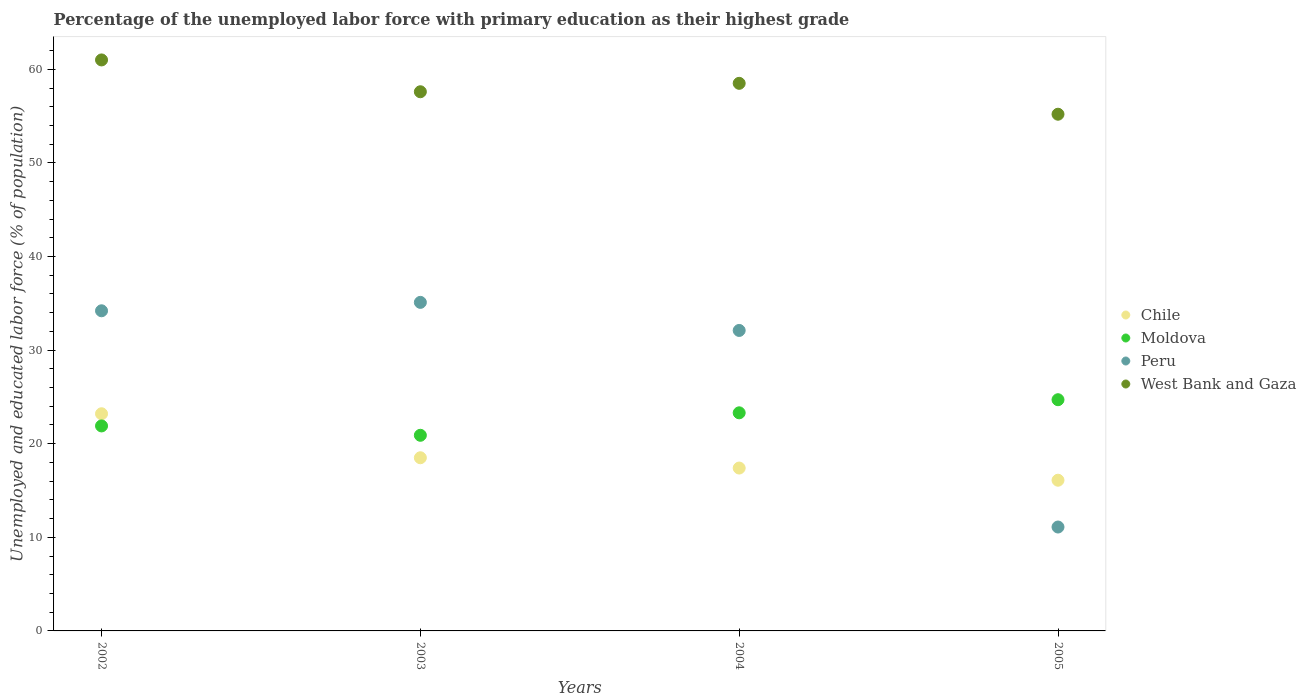How many different coloured dotlines are there?
Make the answer very short. 4. Is the number of dotlines equal to the number of legend labels?
Your response must be concise. Yes. What is the percentage of the unemployed labor force with primary education in Moldova in 2003?
Provide a succinct answer. 20.9. Across all years, what is the maximum percentage of the unemployed labor force with primary education in Chile?
Make the answer very short. 23.2. Across all years, what is the minimum percentage of the unemployed labor force with primary education in Peru?
Ensure brevity in your answer.  11.1. What is the total percentage of the unemployed labor force with primary education in Moldova in the graph?
Your answer should be very brief. 90.8. What is the difference between the percentage of the unemployed labor force with primary education in Peru in 2002 and that in 2004?
Offer a very short reply. 2.1. What is the difference between the percentage of the unemployed labor force with primary education in Chile in 2004 and the percentage of the unemployed labor force with primary education in West Bank and Gaza in 2005?
Offer a very short reply. -37.8. What is the average percentage of the unemployed labor force with primary education in Chile per year?
Offer a terse response. 18.8. In the year 2003, what is the difference between the percentage of the unemployed labor force with primary education in Peru and percentage of the unemployed labor force with primary education in West Bank and Gaza?
Offer a very short reply. -22.5. What is the ratio of the percentage of the unemployed labor force with primary education in Moldova in 2003 to that in 2005?
Your response must be concise. 0.85. What is the difference between the highest and the second highest percentage of the unemployed labor force with primary education in Peru?
Provide a succinct answer. 0.9. What is the difference between the highest and the lowest percentage of the unemployed labor force with primary education in Peru?
Provide a succinct answer. 24. In how many years, is the percentage of the unemployed labor force with primary education in Moldova greater than the average percentage of the unemployed labor force with primary education in Moldova taken over all years?
Your response must be concise. 2. Is it the case that in every year, the sum of the percentage of the unemployed labor force with primary education in Moldova and percentage of the unemployed labor force with primary education in West Bank and Gaza  is greater than the percentage of the unemployed labor force with primary education in Peru?
Offer a terse response. Yes. Does the percentage of the unemployed labor force with primary education in Peru monotonically increase over the years?
Your response must be concise. No. Is the percentage of the unemployed labor force with primary education in West Bank and Gaza strictly greater than the percentage of the unemployed labor force with primary education in Peru over the years?
Make the answer very short. Yes. Is the percentage of the unemployed labor force with primary education in Peru strictly less than the percentage of the unemployed labor force with primary education in Moldova over the years?
Your answer should be compact. No. How many dotlines are there?
Ensure brevity in your answer.  4. Are the values on the major ticks of Y-axis written in scientific E-notation?
Provide a succinct answer. No. Does the graph contain any zero values?
Offer a very short reply. No. Where does the legend appear in the graph?
Offer a very short reply. Center right. How many legend labels are there?
Offer a terse response. 4. What is the title of the graph?
Ensure brevity in your answer.  Percentage of the unemployed labor force with primary education as their highest grade. Does "Papua New Guinea" appear as one of the legend labels in the graph?
Your answer should be compact. No. What is the label or title of the Y-axis?
Your response must be concise. Unemployed and educated labor force (% of population). What is the Unemployed and educated labor force (% of population) in Chile in 2002?
Your answer should be compact. 23.2. What is the Unemployed and educated labor force (% of population) of Moldova in 2002?
Make the answer very short. 21.9. What is the Unemployed and educated labor force (% of population) in Peru in 2002?
Give a very brief answer. 34.2. What is the Unemployed and educated labor force (% of population) in Chile in 2003?
Keep it short and to the point. 18.5. What is the Unemployed and educated labor force (% of population) of Moldova in 2003?
Ensure brevity in your answer.  20.9. What is the Unemployed and educated labor force (% of population) of Peru in 2003?
Offer a terse response. 35.1. What is the Unemployed and educated labor force (% of population) in West Bank and Gaza in 2003?
Offer a terse response. 57.6. What is the Unemployed and educated labor force (% of population) in Chile in 2004?
Your answer should be compact. 17.4. What is the Unemployed and educated labor force (% of population) of Moldova in 2004?
Ensure brevity in your answer.  23.3. What is the Unemployed and educated labor force (% of population) in Peru in 2004?
Your answer should be very brief. 32.1. What is the Unemployed and educated labor force (% of population) in West Bank and Gaza in 2004?
Ensure brevity in your answer.  58.5. What is the Unemployed and educated labor force (% of population) of Chile in 2005?
Give a very brief answer. 16.1. What is the Unemployed and educated labor force (% of population) in Moldova in 2005?
Your response must be concise. 24.7. What is the Unemployed and educated labor force (% of population) of Peru in 2005?
Give a very brief answer. 11.1. What is the Unemployed and educated labor force (% of population) in West Bank and Gaza in 2005?
Keep it short and to the point. 55.2. Across all years, what is the maximum Unemployed and educated labor force (% of population) in Chile?
Your response must be concise. 23.2. Across all years, what is the maximum Unemployed and educated labor force (% of population) in Moldova?
Keep it short and to the point. 24.7. Across all years, what is the maximum Unemployed and educated labor force (% of population) of Peru?
Ensure brevity in your answer.  35.1. Across all years, what is the minimum Unemployed and educated labor force (% of population) of Chile?
Your response must be concise. 16.1. Across all years, what is the minimum Unemployed and educated labor force (% of population) in Moldova?
Offer a very short reply. 20.9. Across all years, what is the minimum Unemployed and educated labor force (% of population) in Peru?
Offer a very short reply. 11.1. Across all years, what is the minimum Unemployed and educated labor force (% of population) in West Bank and Gaza?
Offer a terse response. 55.2. What is the total Unemployed and educated labor force (% of population) in Chile in the graph?
Offer a very short reply. 75.2. What is the total Unemployed and educated labor force (% of population) in Moldova in the graph?
Your answer should be compact. 90.8. What is the total Unemployed and educated labor force (% of population) of Peru in the graph?
Offer a very short reply. 112.5. What is the total Unemployed and educated labor force (% of population) in West Bank and Gaza in the graph?
Ensure brevity in your answer.  232.3. What is the difference between the Unemployed and educated labor force (% of population) in Chile in 2002 and that in 2003?
Offer a very short reply. 4.7. What is the difference between the Unemployed and educated labor force (% of population) of Peru in 2002 and that in 2003?
Offer a terse response. -0.9. What is the difference between the Unemployed and educated labor force (% of population) in Moldova in 2002 and that in 2005?
Your answer should be compact. -2.8. What is the difference between the Unemployed and educated labor force (% of population) in Peru in 2002 and that in 2005?
Keep it short and to the point. 23.1. What is the difference between the Unemployed and educated labor force (% of population) of West Bank and Gaza in 2002 and that in 2005?
Offer a very short reply. 5.8. What is the difference between the Unemployed and educated labor force (% of population) of Chile in 2003 and that in 2004?
Your response must be concise. 1.1. What is the difference between the Unemployed and educated labor force (% of population) in West Bank and Gaza in 2003 and that in 2004?
Offer a very short reply. -0.9. What is the difference between the Unemployed and educated labor force (% of population) of Moldova in 2003 and that in 2005?
Give a very brief answer. -3.8. What is the difference between the Unemployed and educated labor force (% of population) in Peru in 2003 and that in 2005?
Offer a terse response. 24. What is the difference between the Unemployed and educated labor force (% of population) in Chile in 2004 and that in 2005?
Provide a succinct answer. 1.3. What is the difference between the Unemployed and educated labor force (% of population) in Peru in 2004 and that in 2005?
Offer a very short reply. 21. What is the difference between the Unemployed and educated labor force (% of population) in Chile in 2002 and the Unemployed and educated labor force (% of population) in Moldova in 2003?
Your response must be concise. 2.3. What is the difference between the Unemployed and educated labor force (% of population) in Chile in 2002 and the Unemployed and educated labor force (% of population) in Peru in 2003?
Offer a very short reply. -11.9. What is the difference between the Unemployed and educated labor force (% of population) of Chile in 2002 and the Unemployed and educated labor force (% of population) of West Bank and Gaza in 2003?
Your response must be concise. -34.4. What is the difference between the Unemployed and educated labor force (% of population) in Moldova in 2002 and the Unemployed and educated labor force (% of population) in West Bank and Gaza in 2003?
Offer a terse response. -35.7. What is the difference between the Unemployed and educated labor force (% of population) in Peru in 2002 and the Unemployed and educated labor force (% of population) in West Bank and Gaza in 2003?
Your answer should be compact. -23.4. What is the difference between the Unemployed and educated labor force (% of population) in Chile in 2002 and the Unemployed and educated labor force (% of population) in West Bank and Gaza in 2004?
Provide a succinct answer. -35.3. What is the difference between the Unemployed and educated labor force (% of population) in Moldova in 2002 and the Unemployed and educated labor force (% of population) in West Bank and Gaza in 2004?
Your response must be concise. -36.6. What is the difference between the Unemployed and educated labor force (% of population) in Peru in 2002 and the Unemployed and educated labor force (% of population) in West Bank and Gaza in 2004?
Provide a succinct answer. -24.3. What is the difference between the Unemployed and educated labor force (% of population) of Chile in 2002 and the Unemployed and educated labor force (% of population) of Peru in 2005?
Your answer should be very brief. 12.1. What is the difference between the Unemployed and educated labor force (% of population) of Chile in 2002 and the Unemployed and educated labor force (% of population) of West Bank and Gaza in 2005?
Offer a very short reply. -32. What is the difference between the Unemployed and educated labor force (% of population) in Moldova in 2002 and the Unemployed and educated labor force (% of population) in West Bank and Gaza in 2005?
Offer a very short reply. -33.3. What is the difference between the Unemployed and educated labor force (% of population) of Chile in 2003 and the Unemployed and educated labor force (% of population) of Moldova in 2004?
Your answer should be compact. -4.8. What is the difference between the Unemployed and educated labor force (% of population) of Chile in 2003 and the Unemployed and educated labor force (% of population) of West Bank and Gaza in 2004?
Your response must be concise. -40. What is the difference between the Unemployed and educated labor force (% of population) in Moldova in 2003 and the Unemployed and educated labor force (% of population) in Peru in 2004?
Your response must be concise. -11.2. What is the difference between the Unemployed and educated labor force (% of population) of Moldova in 2003 and the Unemployed and educated labor force (% of population) of West Bank and Gaza in 2004?
Offer a terse response. -37.6. What is the difference between the Unemployed and educated labor force (% of population) in Peru in 2003 and the Unemployed and educated labor force (% of population) in West Bank and Gaza in 2004?
Keep it short and to the point. -23.4. What is the difference between the Unemployed and educated labor force (% of population) of Chile in 2003 and the Unemployed and educated labor force (% of population) of Moldova in 2005?
Your answer should be compact. -6.2. What is the difference between the Unemployed and educated labor force (% of population) of Chile in 2003 and the Unemployed and educated labor force (% of population) of West Bank and Gaza in 2005?
Offer a very short reply. -36.7. What is the difference between the Unemployed and educated labor force (% of population) of Moldova in 2003 and the Unemployed and educated labor force (% of population) of West Bank and Gaza in 2005?
Your response must be concise. -34.3. What is the difference between the Unemployed and educated labor force (% of population) of Peru in 2003 and the Unemployed and educated labor force (% of population) of West Bank and Gaza in 2005?
Offer a terse response. -20.1. What is the difference between the Unemployed and educated labor force (% of population) in Chile in 2004 and the Unemployed and educated labor force (% of population) in West Bank and Gaza in 2005?
Your answer should be compact. -37.8. What is the difference between the Unemployed and educated labor force (% of population) of Moldova in 2004 and the Unemployed and educated labor force (% of population) of Peru in 2005?
Your answer should be compact. 12.2. What is the difference between the Unemployed and educated labor force (% of population) in Moldova in 2004 and the Unemployed and educated labor force (% of population) in West Bank and Gaza in 2005?
Your response must be concise. -31.9. What is the difference between the Unemployed and educated labor force (% of population) of Peru in 2004 and the Unemployed and educated labor force (% of population) of West Bank and Gaza in 2005?
Ensure brevity in your answer.  -23.1. What is the average Unemployed and educated labor force (% of population) in Moldova per year?
Your answer should be very brief. 22.7. What is the average Unemployed and educated labor force (% of population) of Peru per year?
Provide a succinct answer. 28.12. What is the average Unemployed and educated labor force (% of population) in West Bank and Gaza per year?
Your answer should be very brief. 58.08. In the year 2002, what is the difference between the Unemployed and educated labor force (% of population) of Chile and Unemployed and educated labor force (% of population) of Peru?
Provide a short and direct response. -11. In the year 2002, what is the difference between the Unemployed and educated labor force (% of population) in Chile and Unemployed and educated labor force (% of population) in West Bank and Gaza?
Give a very brief answer. -37.8. In the year 2002, what is the difference between the Unemployed and educated labor force (% of population) of Moldova and Unemployed and educated labor force (% of population) of West Bank and Gaza?
Your answer should be very brief. -39.1. In the year 2002, what is the difference between the Unemployed and educated labor force (% of population) in Peru and Unemployed and educated labor force (% of population) in West Bank and Gaza?
Provide a succinct answer. -26.8. In the year 2003, what is the difference between the Unemployed and educated labor force (% of population) in Chile and Unemployed and educated labor force (% of population) in Moldova?
Your answer should be compact. -2.4. In the year 2003, what is the difference between the Unemployed and educated labor force (% of population) of Chile and Unemployed and educated labor force (% of population) of Peru?
Your answer should be compact. -16.6. In the year 2003, what is the difference between the Unemployed and educated labor force (% of population) of Chile and Unemployed and educated labor force (% of population) of West Bank and Gaza?
Make the answer very short. -39.1. In the year 2003, what is the difference between the Unemployed and educated labor force (% of population) in Moldova and Unemployed and educated labor force (% of population) in West Bank and Gaza?
Your answer should be compact. -36.7. In the year 2003, what is the difference between the Unemployed and educated labor force (% of population) of Peru and Unemployed and educated labor force (% of population) of West Bank and Gaza?
Your answer should be very brief. -22.5. In the year 2004, what is the difference between the Unemployed and educated labor force (% of population) in Chile and Unemployed and educated labor force (% of population) in Peru?
Offer a very short reply. -14.7. In the year 2004, what is the difference between the Unemployed and educated labor force (% of population) of Chile and Unemployed and educated labor force (% of population) of West Bank and Gaza?
Provide a short and direct response. -41.1. In the year 2004, what is the difference between the Unemployed and educated labor force (% of population) in Moldova and Unemployed and educated labor force (% of population) in West Bank and Gaza?
Provide a short and direct response. -35.2. In the year 2004, what is the difference between the Unemployed and educated labor force (% of population) of Peru and Unemployed and educated labor force (% of population) of West Bank and Gaza?
Provide a short and direct response. -26.4. In the year 2005, what is the difference between the Unemployed and educated labor force (% of population) in Chile and Unemployed and educated labor force (% of population) in Peru?
Make the answer very short. 5. In the year 2005, what is the difference between the Unemployed and educated labor force (% of population) of Chile and Unemployed and educated labor force (% of population) of West Bank and Gaza?
Ensure brevity in your answer.  -39.1. In the year 2005, what is the difference between the Unemployed and educated labor force (% of population) in Moldova and Unemployed and educated labor force (% of population) in West Bank and Gaza?
Give a very brief answer. -30.5. In the year 2005, what is the difference between the Unemployed and educated labor force (% of population) of Peru and Unemployed and educated labor force (% of population) of West Bank and Gaza?
Your answer should be very brief. -44.1. What is the ratio of the Unemployed and educated labor force (% of population) of Chile in 2002 to that in 2003?
Your answer should be compact. 1.25. What is the ratio of the Unemployed and educated labor force (% of population) of Moldova in 2002 to that in 2003?
Provide a succinct answer. 1.05. What is the ratio of the Unemployed and educated labor force (% of population) in Peru in 2002 to that in 2003?
Make the answer very short. 0.97. What is the ratio of the Unemployed and educated labor force (% of population) of West Bank and Gaza in 2002 to that in 2003?
Keep it short and to the point. 1.06. What is the ratio of the Unemployed and educated labor force (% of population) in Moldova in 2002 to that in 2004?
Keep it short and to the point. 0.94. What is the ratio of the Unemployed and educated labor force (% of population) of Peru in 2002 to that in 2004?
Give a very brief answer. 1.07. What is the ratio of the Unemployed and educated labor force (% of population) in West Bank and Gaza in 2002 to that in 2004?
Give a very brief answer. 1.04. What is the ratio of the Unemployed and educated labor force (% of population) in Chile in 2002 to that in 2005?
Provide a short and direct response. 1.44. What is the ratio of the Unemployed and educated labor force (% of population) in Moldova in 2002 to that in 2005?
Offer a very short reply. 0.89. What is the ratio of the Unemployed and educated labor force (% of population) in Peru in 2002 to that in 2005?
Give a very brief answer. 3.08. What is the ratio of the Unemployed and educated labor force (% of population) in West Bank and Gaza in 2002 to that in 2005?
Keep it short and to the point. 1.11. What is the ratio of the Unemployed and educated labor force (% of population) in Chile in 2003 to that in 2004?
Offer a very short reply. 1.06. What is the ratio of the Unemployed and educated labor force (% of population) in Moldova in 2003 to that in 2004?
Provide a succinct answer. 0.9. What is the ratio of the Unemployed and educated labor force (% of population) of Peru in 2003 to that in 2004?
Your answer should be very brief. 1.09. What is the ratio of the Unemployed and educated labor force (% of population) in West Bank and Gaza in 2003 to that in 2004?
Provide a short and direct response. 0.98. What is the ratio of the Unemployed and educated labor force (% of population) in Chile in 2003 to that in 2005?
Offer a terse response. 1.15. What is the ratio of the Unemployed and educated labor force (% of population) of Moldova in 2003 to that in 2005?
Provide a short and direct response. 0.85. What is the ratio of the Unemployed and educated labor force (% of population) of Peru in 2003 to that in 2005?
Give a very brief answer. 3.16. What is the ratio of the Unemployed and educated labor force (% of population) of West Bank and Gaza in 2003 to that in 2005?
Provide a succinct answer. 1.04. What is the ratio of the Unemployed and educated labor force (% of population) of Chile in 2004 to that in 2005?
Ensure brevity in your answer.  1.08. What is the ratio of the Unemployed and educated labor force (% of population) of Moldova in 2004 to that in 2005?
Keep it short and to the point. 0.94. What is the ratio of the Unemployed and educated labor force (% of population) in Peru in 2004 to that in 2005?
Provide a short and direct response. 2.89. What is the ratio of the Unemployed and educated labor force (% of population) in West Bank and Gaza in 2004 to that in 2005?
Provide a succinct answer. 1.06. What is the difference between the highest and the second highest Unemployed and educated labor force (% of population) in Chile?
Provide a short and direct response. 4.7. What is the difference between the highest and the second highest Unemployed and educated labor force (% of population) of Moldova?
Provide a short and direct response. 1.4. What is the difference between the highest and the second highest Unemployed and educated labor force (% of population) in West Bank and Gaza?
Your response must be concise. 2.5. What is the difference between the highest and the lowest Unemployed and educated labor force (% of population) in Moldova?
Offer a very short reply. 3.8. What is the difference between the highest and the lowest Unemployed and educated labor force (% of population) in Peru?
Make the answer very short. 24. What is the difference between the highest and the lowest Unemployed and educated labor force (% of population) in West Bank and Gaza?
Ensure brevity in your answer.  5.8. 